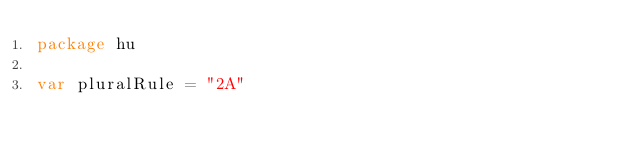<code> <loc_0><loc_0><loc_500><loc_500><_Go_>package hu

var pluralRule = "2A"
</code> 